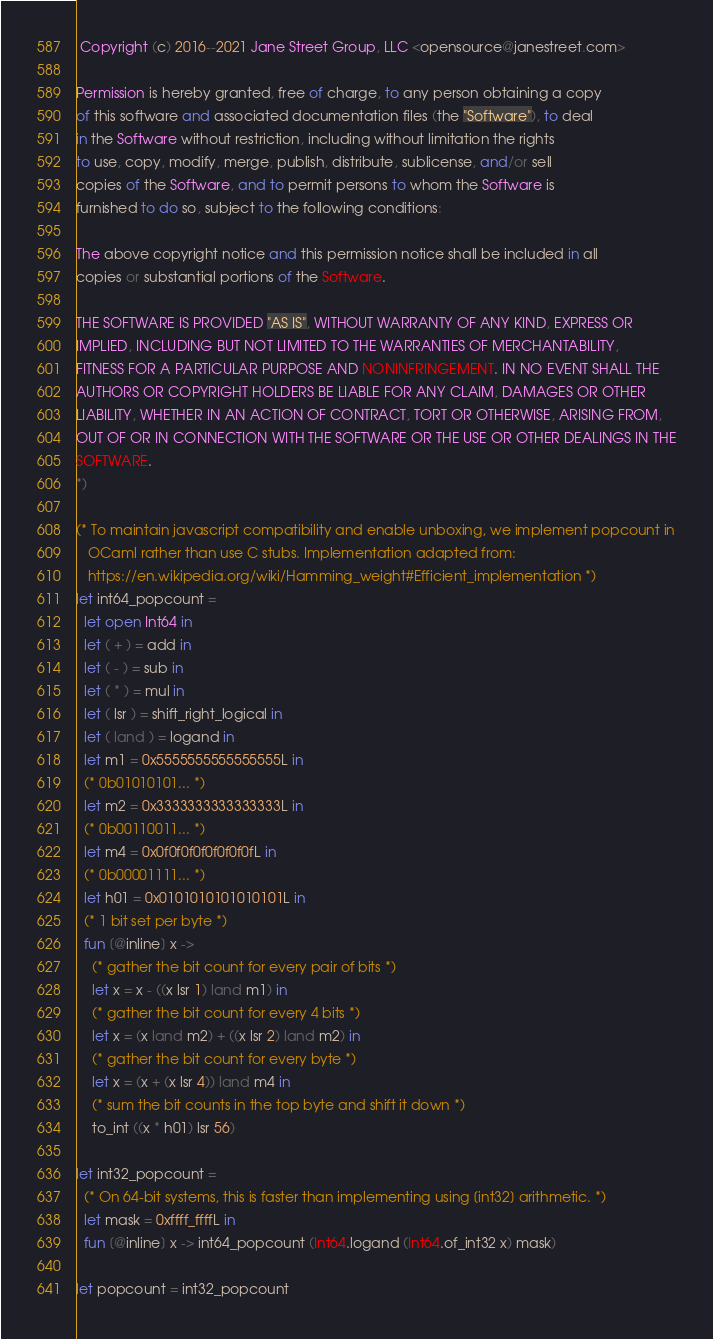<code> <loc_0><loc_0><loc_500><loc_500><_OCaml_> Copyright (c) 2016--2021 Jane Street Group, LLC <opensource@janestreet.com>

Permission is hereby granted, free of charge, to any person obtaining a copy
of this software and associated documentation files (the "Software"), to deal
in the Software without restriction, including without limitation the rights
to use, copy, modify, merge, publish, distribute, sublicense, and/or sell
copies of the Software, and to permit persons to whom the Software is
furnished to do so, subject to the following conditions:

The above copyright notice and this permission notice shall be included in all
copies or substantial portions of the Software.

THE SOFTWARE IS PROVIDED "AS IS", WITHOUT WARRANTY OF ANY KIND, EXPRESS OR
IMPLIED, INCLUDING BUT NOT LIMITED TO THE WARRANTIES OF MERCHANTABILITY,
FITNESS FOR A PARTICULAR PURPOSE AND NONINFRINGEMENT. IN NO EVENT SHALL THE
AUTHORS OR COPYRIGHT HOLDERS BE LIABLE FOR ANY CLAIM, DAMAGES OR OTHER
LIABILITY, WHETHER IN AN ACTION OF CONTRACT, TORT OR OTHERWISE, ARISING FROM,
OUT OF OR IN CONNECTION WITH THE SOFTWARE OR THE USE OR OTHER DEALINGS IN THE
SOFTWARE.
*)

(* To maintain javascript compatibility and enable unboxing, we implement popcount in
   OCaml rather than use C stubs. Implementation adapted from:
   https://en.wikipedia.org/wiki/Hamming_weight#Efficient_implementation *)
let int64_popcount =
  let open Int64 in
  let ( + ) = add in
  let ( - ) = sub in
  let ( * ) = mul in
  let ( lsr ) = shift_right_logical in
  let ( land ) = logand in
  let m1 = 0x5555555555555555L in
  (* 0b01010101... *)
  let m2 = 0x3333333333333333L in
  (* 0b00110011... *)
  let m4 = 0x0f0f0f0f0f0f0f0fL in
  (* 0b00001111... *)
  let h01 = 0x0101010101010101L in
  (* 1 bit set per byte *)
  fun [@inline] x ->
    (* gather the bit count for every pair of bits *)
    let x = x - ((x lsr 1) land m1) in
    (* gather the bit count for every 4 bits *)
    let x = (x land m2) + ((x lsr 2) land m2) in
    (* gather the bit count for every byte *)
    let x = (x + (x lsr 4)) land m4 in
    (* sum the bit counts in the top byte and shift it down *)
    to_int ((x * h01) lsr 56)

let int32_popcount =
  (* On 64-bit systems, this is faster than implementing using [int32] arithmetic. *)
  let mask = 0xffff_ffffL in
  fun [@inline] x -> int64_popcount (Int64.logand (Int64.of_int32 x) mask)

let popcount = int32_popcount
</code> 